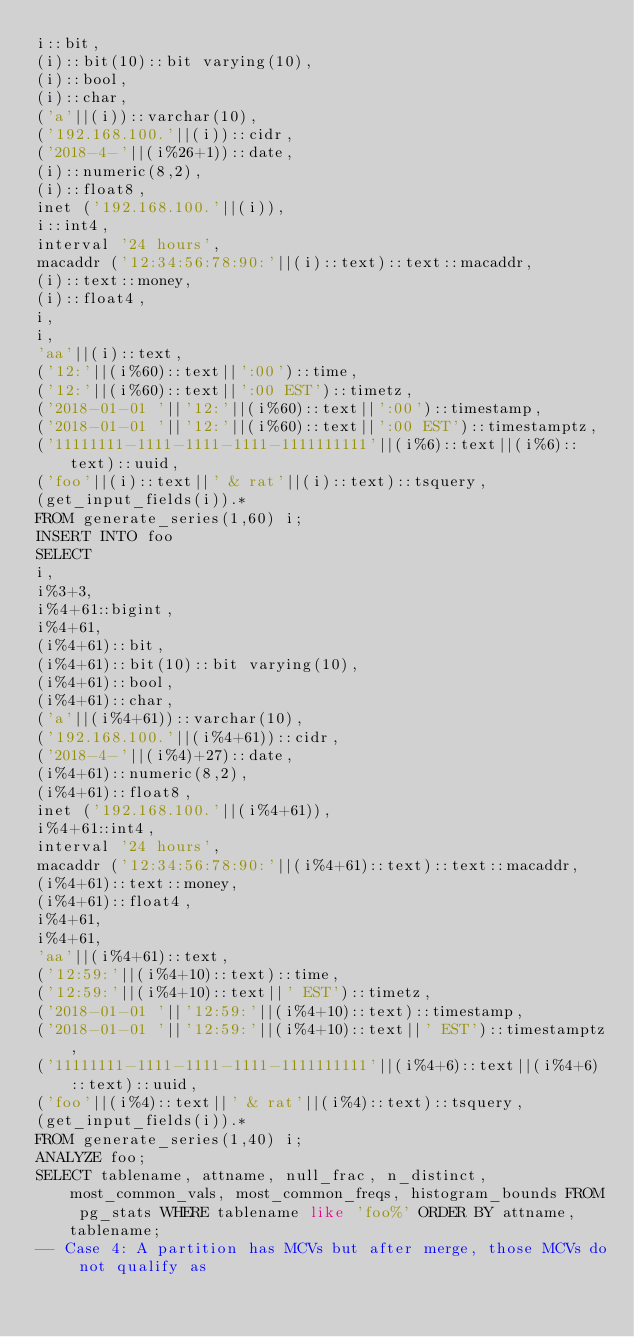<code> <loc_0><loc_0><loc_500><loc_500><_SQL_>i::bit,
(i)::bit(10)::bit varying(10),
(i)::bool,
(i)::char,
('a'||(i))::varchar(10),
('192.168.100.'||(i))::cidr, 
('2018-4-'||(i%26+1))::date, 
(i)::numeric(8,2),
(i)::float8,
inet ('192.168.100.'||(i)),
i::int4,
interval '24 hours',
macaddr ('12:34:56:78:90:'||(i)::text)::text::macaddr,
(i)::text::money,
(i)::float4,
i,
i,
'aa'||(i)::text,
('12:'||(i%60)::text||':00')::time,
('12:'||(i%60)::text||':00 EST')::timetz,
('2018-01-01 '||'12:'||(i%60)::text||':00')::timestamp,
('2018-01-01 '||'12:'||(i%60)::text||':00 EST')::timestamptz,
('11111111-1111-1111-1111-1111111111'||(i%6)::text||(i%6)::text)::uuid,
('foo'||(i)::text||' & rat'||(i)::text)::tsquery,
(get_input_fields(i)).*
FROM generate_series(1,60) i;
INSERT INTO foo 
SELECT
i,
i%3+3,
i%4+61::bigint,
i%4+61,
(i%4+61)::bit,
(i%4+61)::bit(10)::bit varying(10),
(i%4+61)::bool,
(i%4+61)::char,
('a'||(i%4+61))::varchar(10),
('192.168.100.'||(i%4+61))::cidr, 
('2018-4-'||(i%4)+27)::date, 
(i%4+61)::numeric(8,2), 
(i%4+61)::float8,
inet ('192.168.100.'||(i%4+61)),
i%4+61::int4,
interval '24 hours',
macaddr ('12:34:56:78:90:'||(i%4+61)::text)::text::macaddr,
(i%4+61)::text::money,
(i%4+61)::float4, 
i%4+61,
i%4+61,
'aa'||(i%4+61)::text,
('12:59:'||(i%4+10)::text)::time,
('12:59:'||(i%4+10)::text||' EST')::timetz,
('2018-01-01 '||'12:59:'||(i%4+10)::text)::timestamp,
('2018-01-01 '||'12:59:'||(i%4+10)::text||' EST')::timestamptz,
('11111111-1111-1111-1111-1111111111'||(i%4+6)::text||(i%4+6)::text)::uuid,
('foo'||(i%4)::text||' & rat'||(i%4)::text)::tsquery,
(get_input_fields(i)).*
FROM generate_series(1,40) i;
ANALYZE foo;
SELECT tablename, attname, null_frac, n_distinct, most_common_vals, most_common_freqs, histogram_bounds FROM pg_stats WHERE tablename like 'foo%' ORDER BY attname,tablename;
-- Case 4: A partition has MCVs but after merge, those MCVs do not qualify as </code> 